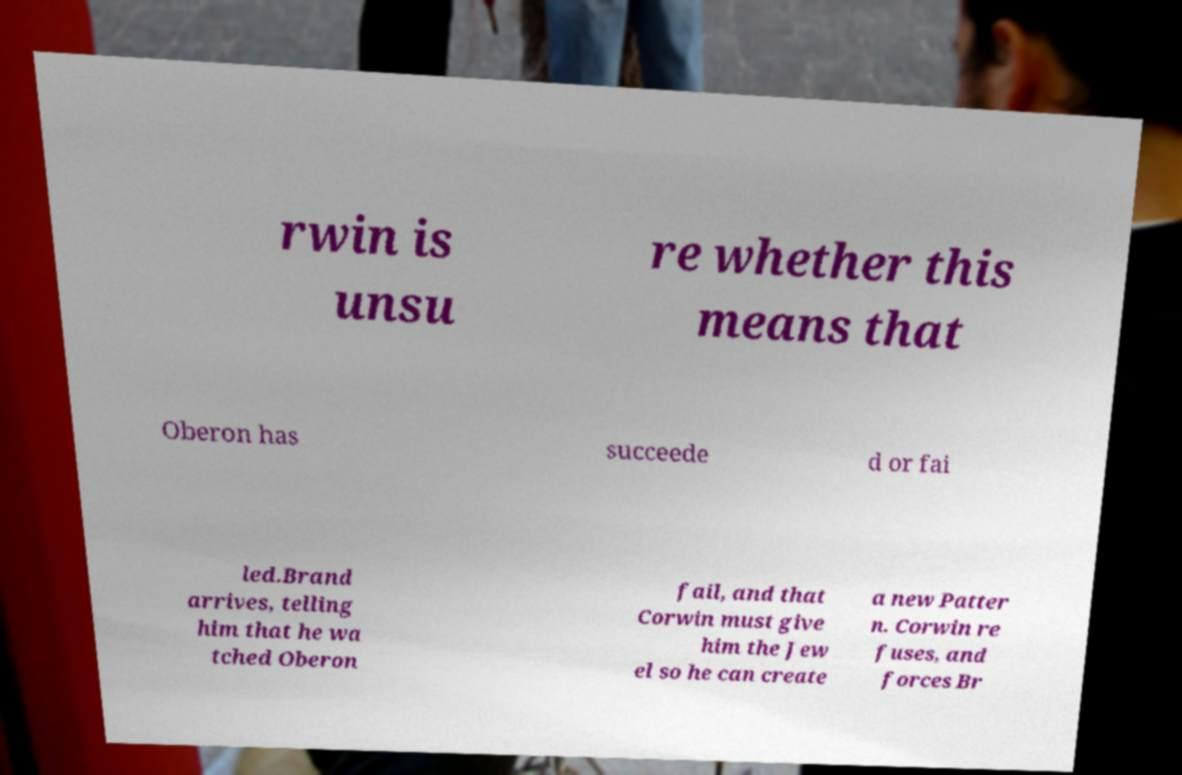For documentation purposes, I need the text within this image transcribed. Could you provide that? rwin is unsu re whether this means that Oberon has succeede d or fai led.Brand arrives, telling him that he wa tched Oberon fail, and that Corwin must give him the Jew el so he can create a new Patter n. Corwin re fuses, and forces Br 